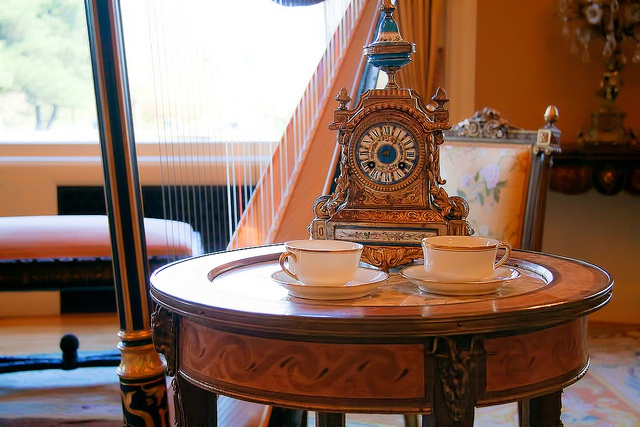Describe the objects in this image and their specific colors. I can see dining table in beige, maroon, black, brown, and white tones, chair in beige, red, darkgray, and maroon tones, bench in beige, black, lavender, and brown tones, cup in beige, tan, lightgray, and brown tones, and cup in beige, tan, salmon, and brown tones in this image. 